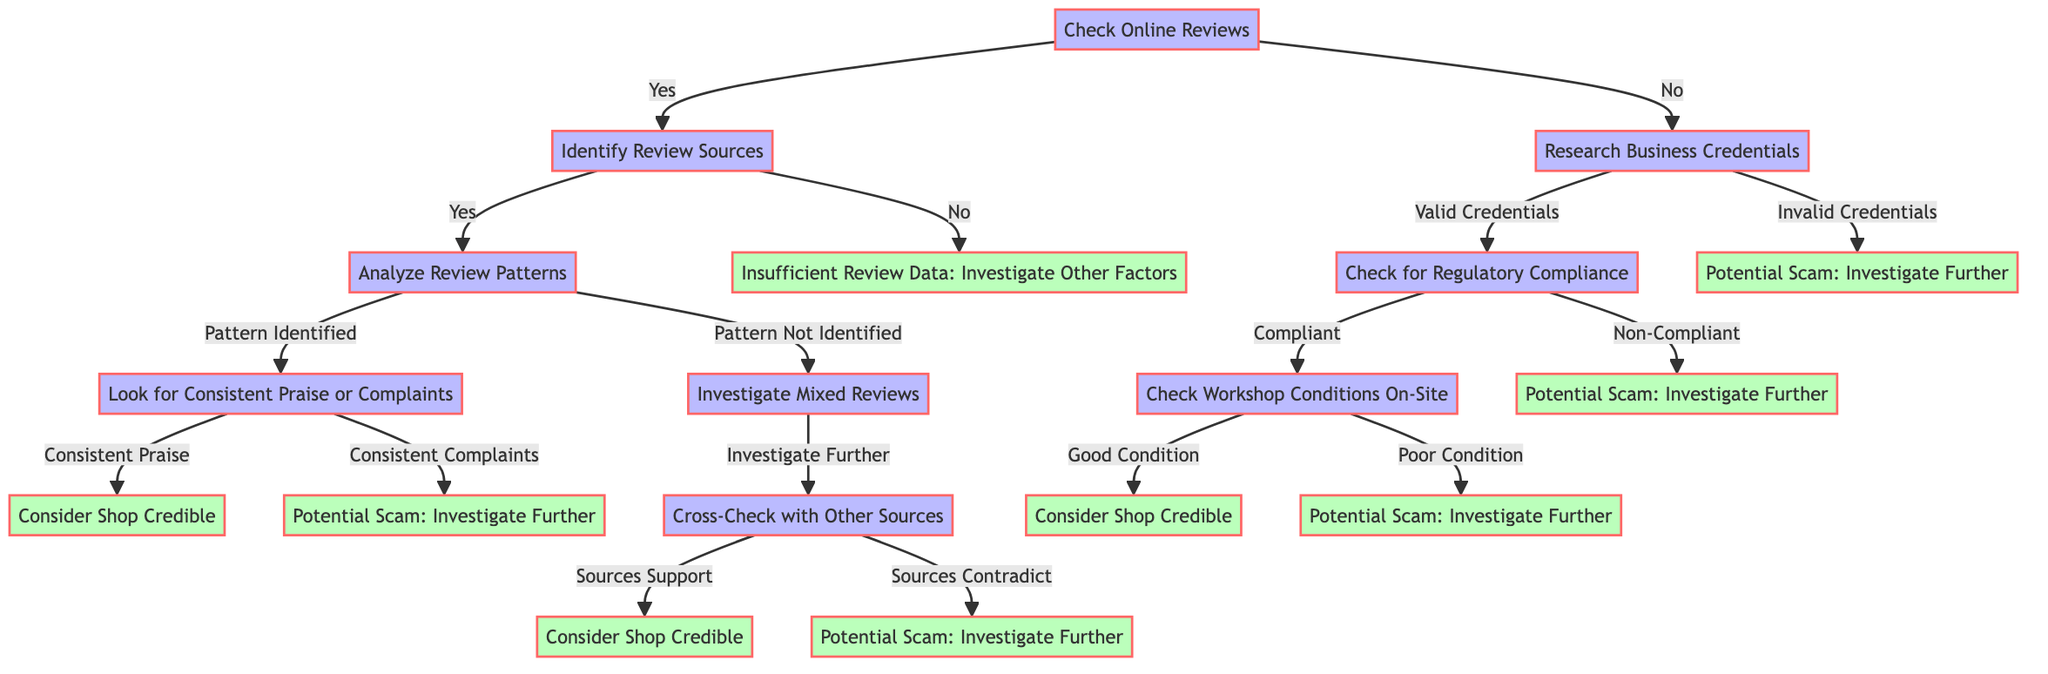What is the first node in the decision tree? The first node in the decision tree is "Check Online Reviews". It is the starting point from which all subsequent decisions branch out.
Answer: Check Online Reviews What leads to a potential scam investigation? A potential scam investigation can be triggered either by identifying inconsistent reviews or finding business credentials invalid or non-compliant. Both routes clearly indicate a lack of credibility.
Answer: Potential Scam: Investigate Further How many nodes are there in total in this decision tree? To count the nodes, we identify every unique decision, outcome, and condition present in the diagram. There are 15 distinct nodes.
Answer: 15 What happens if the online review sources are identified but no patterns are found? If online review sources are identified but no patterns are found, the next step is to "Investigate Mixed Reviews". This indicates uncertainty in the credibility of the shop based on available reviews.
Answer: Investigate Mixed Reviews What node follows if the business credentials are valid and the shop is compliant? If the business credentials are valid and the shop is compliant, the next step is to "Check Workshop Conditions On-Site". This directly assesses the physical condition of the repair facility.
Answer: Check Workshop Conditions On-Site What should you consider if online reviews consistently praise the shop? If online reviews consistently praise the shop, the conclusion is to "Consider Shop Credible". This indicates a strong positive reputation from multiple reviews.
Answer: Consider Shop Credible What is the outcome if workshop conditions are in poor condition? If the workshop conditions are found to be in poor condition during the on-site check, the outcome is "Potential Scam: Investigate Further". This suggests a lack of proper maintenance and professionalism.
Answer: Potential Scam: Investigate Further What is the next action if there is "Insufficient Review Data"? If there is insufficient review data, the next action is to "Investigate Other Factors". This directs you to look into alternative credibility factors besides reviews.
Answer: Investigate Other Factors 